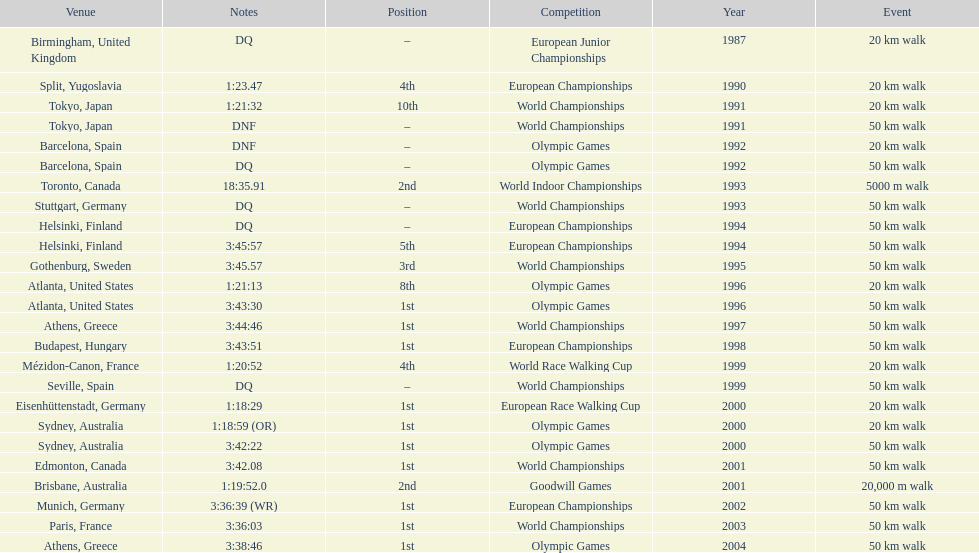In what year was korzeniowski's last competition? 2004. 